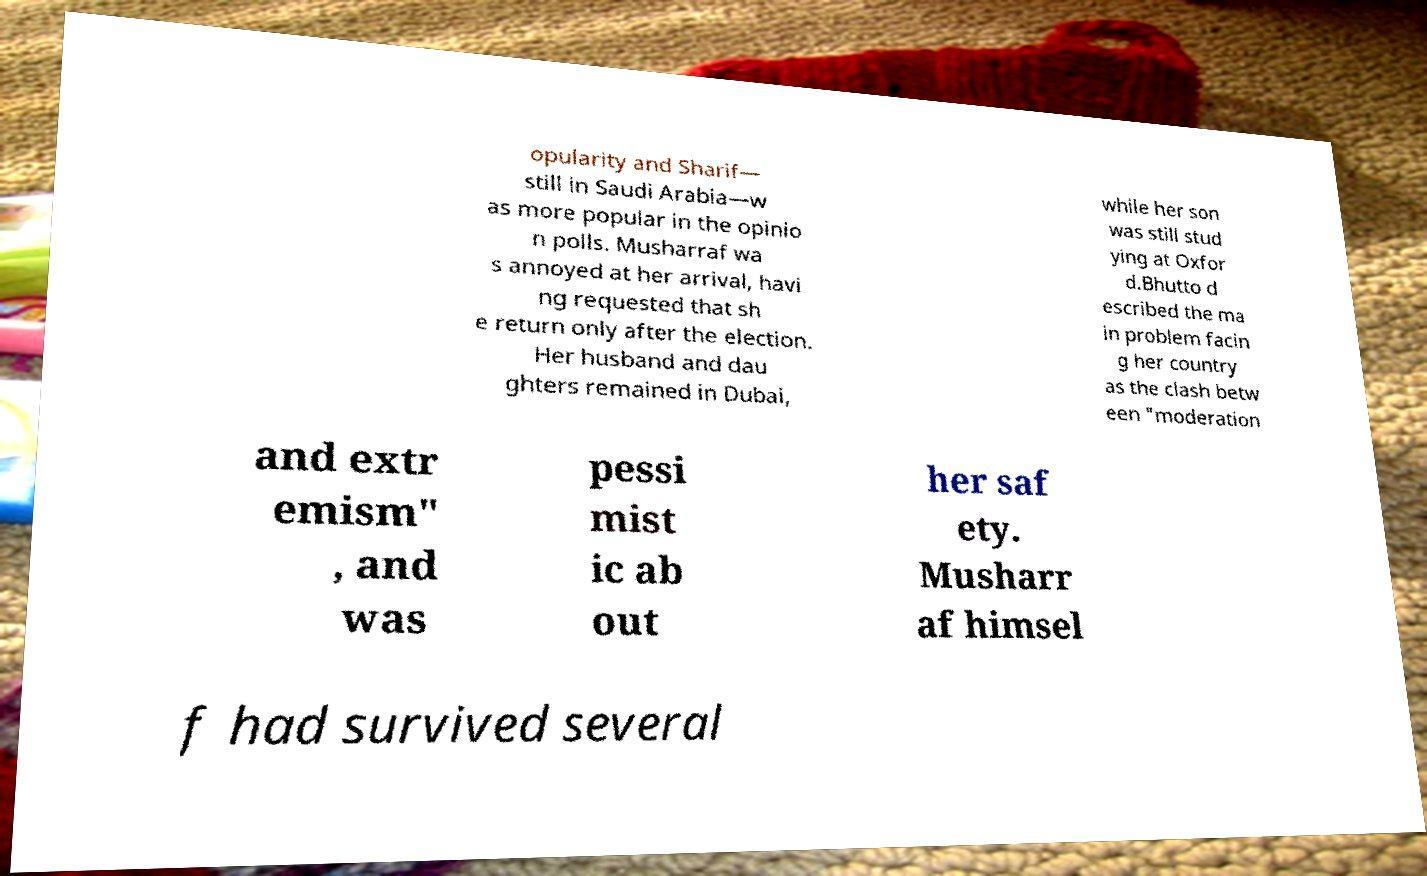Could you extract and type out the text from this image? opularity and Sharif— still in Saudi Arabia—w as more popular in the opinio n polls. Musharraf wa s annoyed at her arrival, havi ng requested that sh e return only after the election. Her husband and dau ghters remained in Dubai, while her son was still stud ying at Oxfor d.Bhutto d escribed the ma in problem facin g her country as the clash betw een "moderation and extr emism" , and was pessi mist ic ab out her saf ety. Musharr af himsel f had survived several 